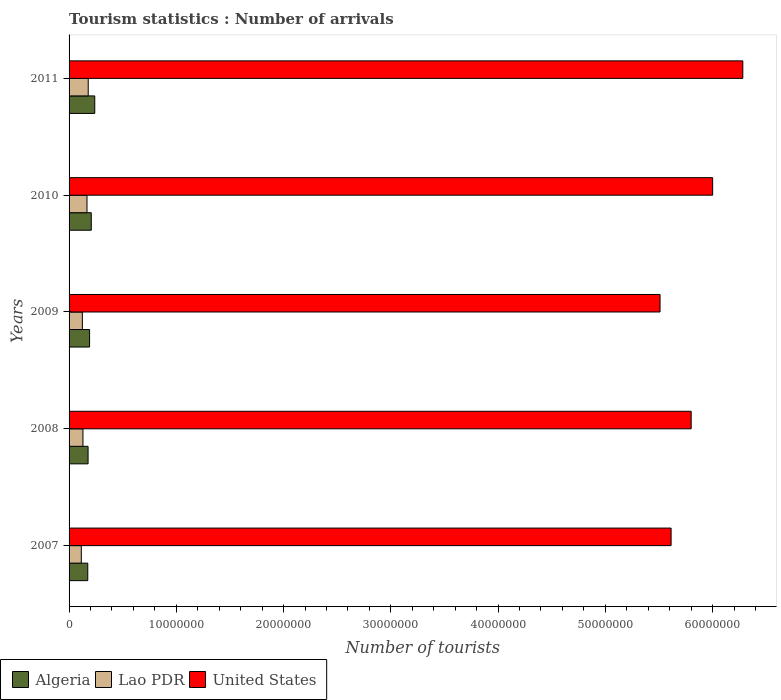How many different coloured bars are there?
Provide a succinct answer. 3. How many groups of bars are there?
Your answer should be compact. 5. Are the number of bars on each tick of the Y-axis equal?
Give a very brief answer. Yes. How many bars are there on the 3rd tick from the top?
Provide a succinct answer. 3. How many bars are there on the 3rd tick from the bottom?
Offer a terse response. 3. What is the label of the 3rd group of bars from the top?
Make the answer very short. 2009. In how many cases, is the number of bars for a given year not equal to the number of legend labels?
Your response must be concise. 0. What is the number of tourist arrivals in Lao PDR in 2011?
Keep it short and to the point. 1.79e+06. Across all years, what is the maximum number of tourist arrivals in United States?
Your response must be concise. 6.28e+07. Across all years, what is the minimum number of tourist arrivals in Lao PDR?
Provide a short and direct response. 1.14e+06. In which year was the number of tourist arrivals in Algeria maximum?
Ensure brevity in your answer.  2011. What is the total number of tourist arrivals in Algeria in the graph?
Offer a terse response. 9.89e+06. What is the difference between the number of tourist arrivals in Algeria in 2008 and that in 2010?
Offer a very short reply. -2.98e+05. What is the difference between the number of tourist arrivals in Lao PDR in 2008 and the number of tourist arrivals in United States in 2007?
Offer a terse response. -5.48e+07. What is the average number of tourist arrivals in Lao PDR per year?
Offer a terse response. 1.43e+06. In the year 2007, what is the difference between the number of tourist arrivals in United States and number of tourist arrivals in Lao PDR?
Your response must be concise. 5.50e+07. What is the ratio of the number of tourist arrivals in Algeria in 2008 to that in 2009?
Your answer should be compact. 0.93. Is the number of tourist arrivals in United States in 2007 less than that in 2011?
Ensure brevity in your answer.  Yes. What is the difference between the highest and the second highest number of tourist arrivals in Algeria?
Offer a very short reply. 3.25e+05. What is the difference between the highest and the lowest number of tourist arrivals in Algeria?
Keep it short and to the point. 6.52e+05. What does the 3rd bar from the bottom in 2007 represents?
Give a very brief answer. United States. How many bars are there?
Offer a very short reply. 15. How many years are there in the graph?
Provide a succinct answer. 5. What is the difference between two consecutive major ticks on the X-axis?
Your response must be concise. 1.00e+07. Are the values on the major ticks of X-axis written in scientific E-notation?
Offer a very short reply. No. Does the graph contain grids?
Give a very brief answer. No. How many legend labels are there?
Make the answer very short. 3. What is the title of the graph?
Your response must be concise. Tourism statistics : Number of arrivals. Does "Central African Republic" appear as one of the legend labels in the graph?
Your answer should be compact. No. What is the label or title of the X-axis?
Make the answer very short. Number of tourists. What is the label or title of the Y-axis?
Give a very brief answer. Years. What is the Number of tourists in Algeria in 2007?
Offer a terse response. 1.74e+06. What is the Number of tourists of Lao PDR in 2007?
Offer a terse response. 1.14e+06. What is the Number of tourists of United States in 2007?
Your answer should be very brief. 5.61e+07. What is the Number of tourists of Algeria in 2008?
Your answer should be very brief. 1.77e+06. What is the Number of tourists of Lao PDR in 2008?
Ensure brevity in your answer.  1.30e+06. What is the Number of tourists in United States in 2008?
Offer a terse response. 5.80e+07. What is the Number of tourists in Algeria in 2009?
Offer a terse response. 1.91e+06. What is the Number of tourists in Lao PDR in 2009?
Keep it short and to the point. 1.24e+06. What is the Number of tourists of United States in 2009?
Provide a succinct answer. 5.51e+07. What is the Number of tourists of Algeria in 2010?
Keep it short and to the point. 2.07e+06. What is the Number of tourists in Lao PDR in 2010?
Provide a succinct answer. 1.67e+06. What is the Number of tourists in United States in 2010?
Provide a short and direct response. 6.00e+07. What is the Number of tourists in Algeria in 2011?
Make the answer very short. 2.40e+06. What is the Number of tourists of Lao PDR in 2011?
Keep it short and to the point. 1.79e+06. What is the Number of tourists in United States in 2011?
Keep it short and to the point. 6.28e+07. Across all years, what is the maximum Number of tourists in Algeria?
Provide a short and direct response. 2.40e+06. Across all years, what is the maximum Number of tourists in Lao PDR?
Offer a terse response. 1.79e+06. Across all years, what is the maximum Number of tourists of United States?
Provide a succinct answer. 6.28e+07. Across all years, what is the minimum Number of tourists in Algeria?
Keep it short and to the point. 1.74e+06. Across all years, what is the minimum Number of tourists of Lao PDR?
Your response must be concise. 1.14e+06. Across all years, what is the minimum Number of tourists of United States?
Give a very brief answer. 5.51e+07. What is the total Number of tourists of Algeria in the graph?
Offer a very short reply. 9.89e+06. What is the total Number of tourists of Lao PDR in the graph?
Provide a succinct answer. 7.13e+06. What is the total Number of tourists of United States in the graph?
Make the answer very short. 2.92e+08. What is the difference between the Number of tourists of Algeria in 2007 and that in 2008?
Ensure brevity in your answer.  -2.90e+04. What is the difference between the Number of tourists of Lao PDR in 2007 and that in 2008?
Provide a succinct answer. -1.53e+05. What is the difference between the Number of tourists in United States in 2007 and that in 2008?
Keep it short and to the point. -1.87e+06. What is the difference between the Number of tourists of Algeria in 2007 and that in 2009?
Provide a short and direct response. -1.69e+05. What is the difference between the Number of tourists in Lao PDR in 2007 and that in 2009?
Give a very brief answer. -9.70e+04. What is the difference between the Number of tourists of United States in 2007 and that in 2009?
Keep it short and to the point. 1.03e+06. What is the difference between the Number of tourists of Algeria in 2007 and that in 2010?
Keep it short and to the point. -3.27e+05. What is the difference between the Number of tourists in Lao PDR in 2007 and that in 2010?
Make the answer very short. -5.28e+05. What is the difference between the Number of tourists in United States in 2007 and that in 2010?
Give a very brief answer. -3.88e+06. What is the difference between the Number of tourists of Algeria in 2007 and that in 2011?
Give a very brief answer. -6.52e+05. What is the difference between the Number of tourists in Lao PDR in 2007 and that in 2011?
Offer a terse response. -6.44e+05. What is the difference between the Number of tourists of United States in 2007 and that in 2011?
Provide a succinct answer. -6.69e+06. What is the difference between the Number of tourists in Lao PDR in 2008 and that in 2009?
Provide a succinct answer. 5.60e+04. What is the difference between the Number of tourists in United States in 2008 and that in 2009?
Your answer should be very brief. 2.90e+06. What is the difference between the Number of tourists in Algeria in 2008 and that in 2010?
Provide a succinct answer. -2.98e+05. What is the difference between the Number of tourists in Lao PDR in 2008 and that in 2010?
Offer a terse response. -3.75e+05. What is the difference between the Number of tourists of United States in 2008 and that in 2010?
Your answer should be compact. -2.00e+06. What is the difference between the Number of tourists in Algeria in 2008 and that in 2011?
Offer a very short reply. -6.23e+05. What is the difference between the Number of tourists of Lao PDR in 2008 and that in 2011?
Give a very brief answer. -4.91e+05. What is the difference between the Number of tourists in United States in 2008 and that in 2011?
Provide a short and direct response. -4.81e+06. What is the difference between the Number of tourists of Algeria in 2009 and that in 2010?
Ensure brevity in your answer.  -1.58e+05. What is the difference between the Number of tourists in Lao PDR in 2009 and that in 2010?
Offer a very short reply. -4.31e+05. What is the difference between the Number of tourists in United States in 2009 and that in 2010?
Your answer should be very brief. -4.91e+06. What is the difference between the Number of tourists of Algeria in 2009 and that in 2011?
Ensure brevity in your answer.  -4.83e+05. What is the difference between the Number of tourists of Lao PDR in 2009 and that in 2011?
Provide a succinct answer. -5.47e+05. What is the difference between the Number of tourists in United States in 2009 and that in 2011?
Your answer should be very brief. -7.72e+06. What is the difference between the Number of tourists of Algeria in 2010 and that in 2011?
Offer a terse response. -3.25e+05. What is the difference between the Number of tourists in Lao PDR in 2010 and that in 2011?
Give a very brief answer. -1.16e+05. What is the difference between the Number of tourists in United States in 2010 and that in 2011?
Offer a very short reply. -2.81e+06. What is the difference between the Number of tourists in Algeria in 2007 and the Number of tourists in Lao PDR in 2008?
Offer a terse response. 4.48e+05. What is the difference between the Number of tourists of Algeria in 2007 and the Number of tourists of United States in 2008?
Provide a short and direct response. -5.63e+07. What is the difference between the Number of tourists in Lao PDR in 2007 and the Number of tourists in United States in 2008?
Ensure brevity in your answer.  -5.69e+07. What is the difference between the Number of tourists of Algeria in 2007 and the Number of tourists of Lao PDR in 2009?
Keep it short and to the point. 5.04e+05. What is the difference between the Number of tourists of Algeria in 2007 and the Number of tourists of United States in 2009?
Provide a succinct answer. -5.34e+07. What is the difference between the Number of tourists in Lao PDR in 2007 and the Number of tourists in United States in 2009?
Your answer should be compact. -5.40e+07. What is the difference between the Number of tourists of Algeria in 2007 and the Number of tourists of Lao PDR in 2010?
Offer a very short reply. 7.30e+04. What is the difference between the Number of tourists in Algeria in 2007 and the Number of tourists in United States in 2010?
Provide a short and direct response. -5.83e+07. What is the difference between the Number of tourists of Lao PDR in 2007 and the Number of tourists of United States in 2010?
Provide a succinct answer. -5.89e+07. What is the difference between the Number of tourists in Algeria in 2007 and the Number of tourists in Lao PDR in 2011?
Keep it short and to the point. -4.30e+04. What is the difference between the Number of tourists in Algeria in 2007 and the Number of tourists in United States in 2011?
Your answer should be compact. -6.11e+07. What is the difference between the Number of tourists of Lao PDR in 2007 and the Number of tourists of United States in 2011?
Keep it short and to the point. -6.17e+07. What is the difference between the Number of tourists of Algeria in 2008 and the Number of tourists of Lao PDR in 2009?
Give a very brief answer. 5.33e+05. What is the difference between the Number of tourists of Algeria in 2008 and the Number of tourists of United States in 2009?
Ensure brevity in your answer.  -5.33e+07. What is the difference between the Number of tourists of Lao PDR in 2008 and the Number of tourists of United States in 2009?
Your response must be concise. -5.38e+07. What is the difference between the Number of tourists of Algeria in 2008 and the Number of tourists of Lao PDR in 2010?
Make the answer very short. 1.02e+05. What is the difference between the Number of tourists in Algeria in 2008 and the Number of tourists in United States in 2010?
Provide a succinct answer. -5.82e+07. What is the difference between the Number of tourists in Lao PDR in 2008 and the Number of tourists in United States in 2010?
Provide a short and direct response. -5.87e+07. What is the difference between the Number of tourists in Algeria in 2008 and the Number of tourists in Lao PDR in 2011?
Keep it short and to the point. -1.40e+04. What is the difference between the Number of tourists of Algeria in 2008 and the Number of tourists of United States in 2011?
Your response must be concise. -6.10e+07. What is the difference between the Number of tourists in Lao PDR in 2008 and the Number of tourists in United States in 2011?
Your answer should be compact. -6.15e+07. What is the difference between the Number of tourists of Algeria in 2009 and the Number of tourists of Lao PDR in 2010?
Provide a succinct answer. 2.42e+05. What is the difference between the Number of tourists in Algeria in 2009 and the Number of tourists in United States in 2010?
Make the answer very short. -5.81e+07. What is the difference between the Number of tourists of Lao PDR in 2009 and the Number of tourists of United States in 2010?
Keep it short and to the point. -5.88e+07. What is the difference between the Number of tourists in Algeria in 2009 and the Number of tourists in Lao PDR in 2011?
Your answer should be very brief. 1.26e+05. What is the difference between the Number of tourists in Algeria in 2009 and the Number of tourists in United States in 2011?
Give a very brief answer. -6.09e+07. What is the difference between the Number of tourists of Lao PDR in 2009 and the Number of tourists of United States in 2011?
Your response must be concise. -6.16e+07. What is the difference between the Number of tourists of Algeria in 2010 and the Number of tourists of Lao PDR in 2011?
Offer a terse response. 2.84e+05. What is the difference between the Number of tourists in Algeria in 2010 and the Number of tourists in United States in 2011?
Offer a terse response. -6.08e+07. What is the difference between the Number of tourists in Lao PDR in 2010 and the Number of tourists in United States in 2011?
Your answer should be very brief. -6.12e+07. What is the average Number of tourists in Algeria per year?
Offer a very short reply. 1.98e+06. What is the average Number of tourists of Lao PDR per year?
Offer a very short reply. 1.43e+06. What is the average Number of tourists in United States per year?
Your response must be concise. 5.84e+07. In the year 2007, what is the difference between the Number of tourists of Algeria and Number of tourists of Lao PDR?
Offer a very short reply. 6.01e+05. In the year 2007, what is the difference between the Number of tourists of Algeria and Number of tourists of United States?
Provide a succinct answer. -5.44e+07. In the year 2007, what is the difference between the Number of tourists of Lao PDR and Number of tourists of United States?
Your response must be concise. -5.50e+07. In the year 2008, what is the difference between the Number of tourists of Algeria and Number of tourists of Lao PDR?
Make the answer very short. 4.77e+05. In the year 2008, what is the difference between the Number of tourists of Algeria and Number of tourists of United States?
Offer a very short reply. -5.62e+07. In the year 2008, what is the difference between the Number of tourists in Lao PDR and Number of tourists in United States?
Your response must be concise. -5.67e+07. In the year 2009, what is the difference between the Number of tourists in Algeria and Number of tourists in Lao PDR?
Your response must be concise. 6.73e+05. In the year 2009, what is the difference between the Number of tourists of Algeria and Number of tourists of United States?
Your answer should be very brief. -5.32e+07. In the year 2009, what is the difference between the Number of tourists in Lao PDR and Number of tourists in United States?
Keep it short and to the point. -5.39e+07. In the year 2010, what is the difference between the Number of tourists of Algeria and Number of tourists of Lao PDR?
Ensure brevity in your answer.  4.00e+05. In the year 2010, what is the difference between the Number of tourists of Algeria and Number of tourists of United States?
Provide a succinct answer. -5.79e+07. In the year 2010, what is the difference between the Number of tourists of Lao PDR and Number of tourists of United States?
Your answer should be very brief. -5.83e+07. In the year 2011, what is the difference between the Number of tourists in Algeria and Number of tourists in Lao PDR?
Your answer should be very brief. 6.09e+05. In the year 2011, what is the difference between the Number of tourists in Algeria and Number of tourists in United States?
Make the answer very short. -6.04e+07. In the year 2011, what is the difference between the Number of tourists in Lao PDR and Number of tourists in United States?
Your answer should be very brief. -6.10e+07. What is the ratio of the Number of tourists of Algeria in 2007 to that in 2008?
Your answer should be compact. 0.98. What is the ratio of the Number of tourists in Lao PDR in 2007 to that in 2008?
Your response must be concise. 0.88. What is the ratio of the Number of tourists in Algeria in 2007 to that in 2009?
Make the answer very short. 0.91. What is the ratio of the Number of tourists of Lao PDR in 2007 to that in 2009?
Offer a very short reply. 0.92. What is the ratio of the Number of tourists of United States in 2007 to that in 2009?
Provide a short and direct response. 1.02. What is the ratio of the Number of tourists in Algeria in 2007 to that in 2010?
Provide a succinct answer. 0.84. What is the ratio of the Number of tourists of Lao PDR in 2007 to that in 2010?
Keep it short and to the point. 0.68. What is the ratio of the Number of tourists of United States in 2007 to that in 2010?
Your answer should be very brief. 0.94. What is the ratio of the Number of tourists in Algeria in 2007 to that in 2011?
Provide a short and direct response. 0.73. What is the ratio of the Number of tourists in Lao PDR in 2007 to that in 2011?
Give a very brief answer. 0.64. What is the ratio of the Number of tourists of United States in 2007 to that in 2011?
Your response must be concise. 0.89. What is the ratio of the Number of tourists in Algeria in 2008 to that in 2009?
Keep it short and to the point. 0.93. What is the ratio of the Number of tourists of Lao PDR in 2008 to that in 2009?
Keep it short and to the point. 1.05. What is the ratio of the Number of tourists of United States in 2008 to that in 2009?
Offer a terse response. 1.05. What is the ratio of the Number of tourists in Algeria in 2008 to that in 2010?
Your answer should be compact. 0.86. What is the ratio of the Number of tourists of Lao PDR in 2008 to that in 2010?
Provide a succinct answer. 0.78. What is the ratio of the Number of tourists of United States in 2008 to that in 2010?
Keep it short and to the point. 0.97. What is the ratio of the Number of tourists in Algeria in 2008 to that in 2011?
Ensure brevity in your answer.  0.74. What is the ratio of the Number of tourists of Lao PDR in 2008 to that in 2011?
Provide a succinct answer. 0.73. What is the ratio of the Number of tourists of United States in 2008 to that in 2011?
Provide a succinct answer. 0.92. What is the ratio of the Number of tourists of Algeria in 2009 to that in 2010?
Your answer should be compact. 0.92. What is the ratio of the Number of tourists in Lao PDR in 2009 to that in 2010?
Your answer should be very brief. 0.74. What is the ratio of the Number of tourists in United States in 2009 to that in 2010?
Keep it short and to the point. 0.92. What is the ratio of the Number of tourists of Algeria in 2009 to that in 2011?
Offer a very short reply. 0.8. What is the ratio of the Number of tourists of Lao PDR in 2009 to that in 2011?
Provide a short and direct response. 0.69. What is the ratio of the Number of tourists of United States in 2009 to that in 2011?
Your answer should be compact. 0.88. What is the ratio of the Number of tourists of Algeria in 2010 to that in 2011?
Provide a succinct answer. 0.86. What is the ratio of the Number of tourists in Lao PDR in 2010 to that in 2011?
Offer a very short reply. 0.94. What is the ratio of the Number of tourists of United States in 2010 to that in 2011?
Offer a terse response. 0.96. What is the difference between the highest and the second highest Number of tourists of Algeria?
Provide a succinct answer. 3.25e+05. What is the difference between the highest and the second highest Number of tourists of Lao PDR?
Offer a terse response. 1.16e+05. What is the difference between the highest and the second highest Number of tourists of United States?
Ensure brevity in your answer.  2.81e+06. What is the difference between the highest and the lowest Number of tourists of Algeria?
Offer a very short reply. 6.52e+05. What is the difference between the highest and the lowest Number of tourists in Lao PDR?
Keep it short and to the point. 6.44e+05. What is the difference between the highest and the lowest Number of tourists in United States?
Give a very brief answer. 7.72e+06. 